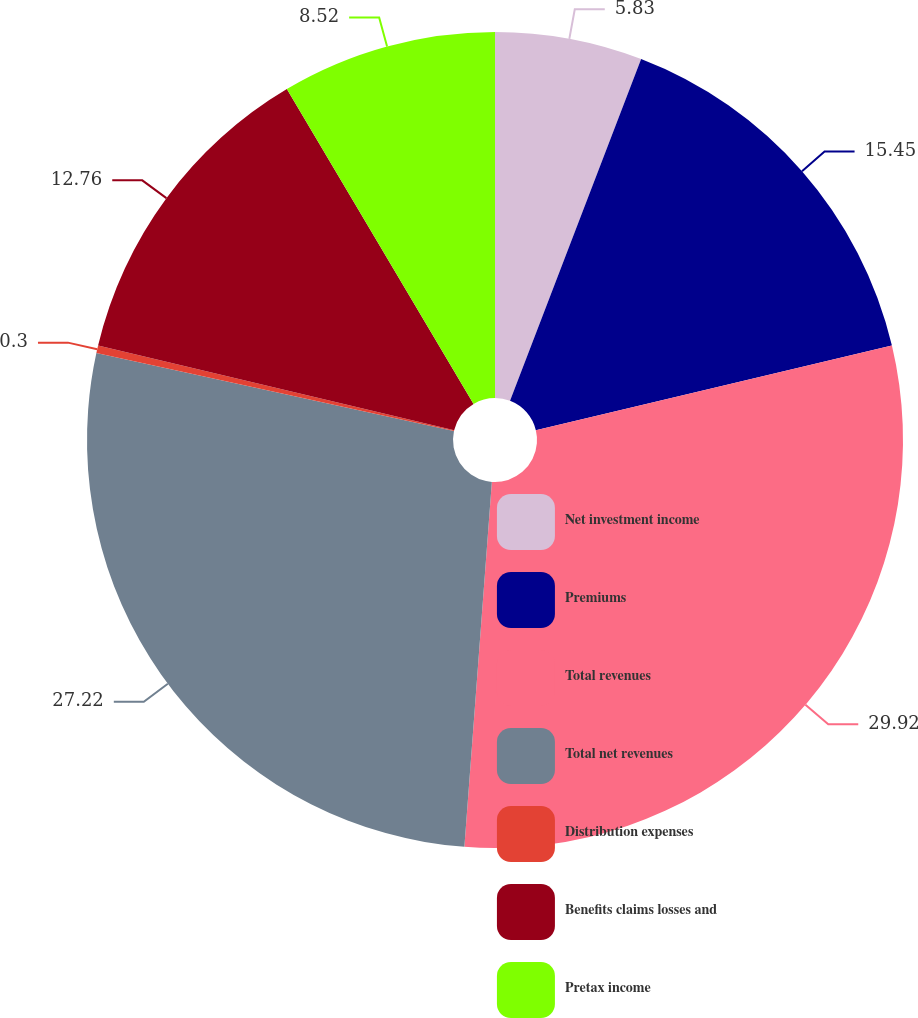<chart> <loc_0><loc_0><loc_500><loc_500><pie_chart><fcel>Net investment income<fcel>Premiums<fcel>Total revenues<fcel>Total net revenues<fcel>Distribution expenses<fcel>Benefits claims losses and<fcel>Pretax income<nl><fcel>5.83%<fcel>15.45%<fcel>29.91%<fcel>27.22%<fcel>0.3%<fcel>12.76%<fcel>8.52%<nl></chart> 